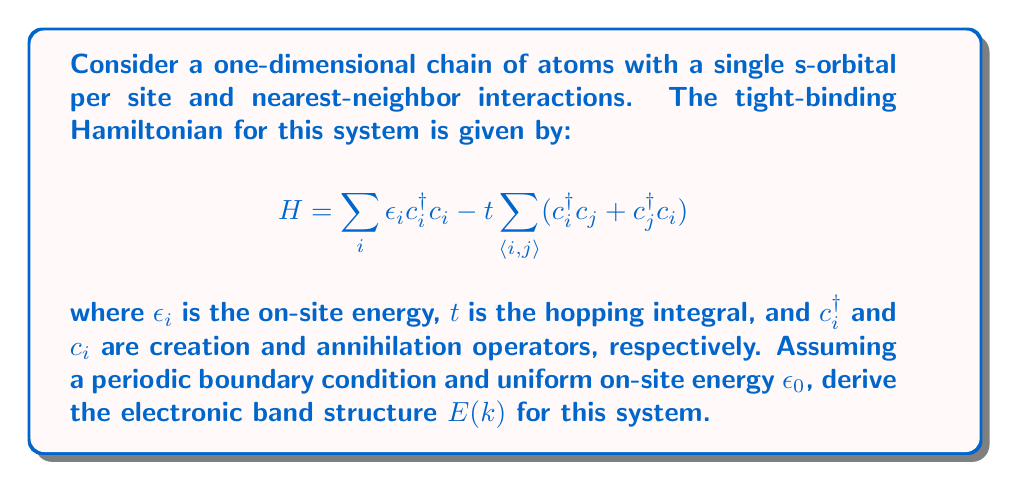Solve this math problem. To solve this problem, we'll follow these steps:

1) First, we apply Bloch's theorem to express the wavefunction in terms of Bloch states:

   $$ \psi_k(x) = \frac{1}{\sqrt{N}} \sum_n e^{ikna} \phi(x-na) $$

   where $a$ is the lattice constant and $N$ is the number of atoms.

2) We then express the Hamiltonian in k-space:

   $$ H_k = \epsilon_0 - 2t \cos(ka) $$

3) The eigenvalues of this Hamiltonian give us the energy bands. Therefore, the electronic band structure $E(k)$ is:

   $$ E(k) = \epsilon_0 - 2t \cos(ka) $$

4) This represents a single energy band that varies sinusoidally with $k$. The bandwidth is $4t$, ranging from $\epsilon_0 - 2t$ to $\epsilon_0 + 2t$.

5) The dispersion relation is periodic in $k$ with a period of $2\pi/a$, which defines the first Brillouin zone: $-\pi/a \leq k \leq \pi/a$.

This simple model provides insights into the electronic properties of the material. The band structure shows how the energy of electrons varies with their crystal momentum, which is crucial for understanding properties like electrical conductivity and optical absorption in energy materials.
Answer: $E(k) = \epsilon_0 - 2t \cos(ka)$ 